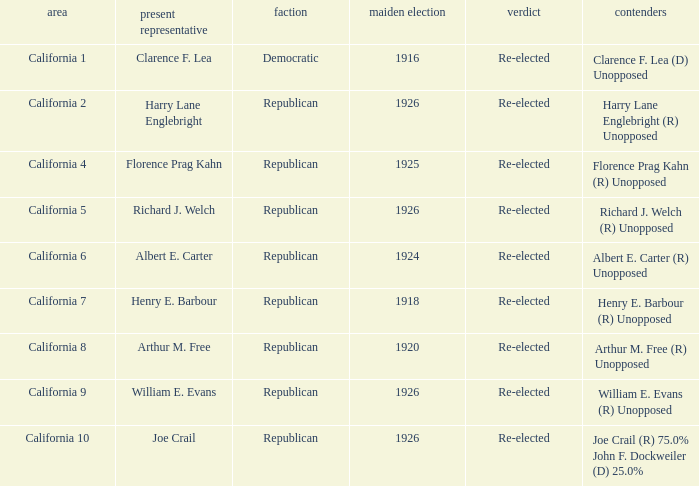Parse the table in full. {'header': ['area', 'present representative', 'faction', 'maiden election', 'verdict', 'contenders'], 'rows': [['California 1', 'Clarence F. Lea', 'Democratic', '1916', 'Re-elected', 'Clarence F. Lea (D) Unopposed'], ['California 2', 'Harry Lane Englebright', 'Republican', '1926', 'Re-elected', 'Harry Lane Englebright (R) Unopposed'], ['California 4', 'Florence Prag Kahn', 'Republican', '1925', 'Re-elected', 'Florence Prag Kahn (R) Unopposed'], ['California 5', 'Richard J. Welch', 'Republican', '1926', 'Re-elected', 'Richard J. Welch (R) Unopposed'], ['California 6', 'Albert E. Carter', 'Republican', '1924', 'Re-elected', 'Albert E. Carter (R) Unopposed'], ['California 7', 'Henry E. Barbour', 'Republican', '1918', 'Re-elected', 'Henry E. Barbour (R) Unopposed'], ['California 8', 'Arthur M. Free', 'Republican', '1920', 'Re-elected', 'Arthur M. Free (R) Unopposed'], ['California 9', 'William E. Evans', 'Republican', '1926', 'Re-elected', 'William E. Evans (R) Unopposed'], ['California 10', 'Joe Crail', 'Republican', '1926', 'Re-elected', 'Joe Crail (R) 75.0% John F. Dockweiler (D) 25.0%']]} What's the district with candidates being harry lane englebright (r) unopposed California 2. 